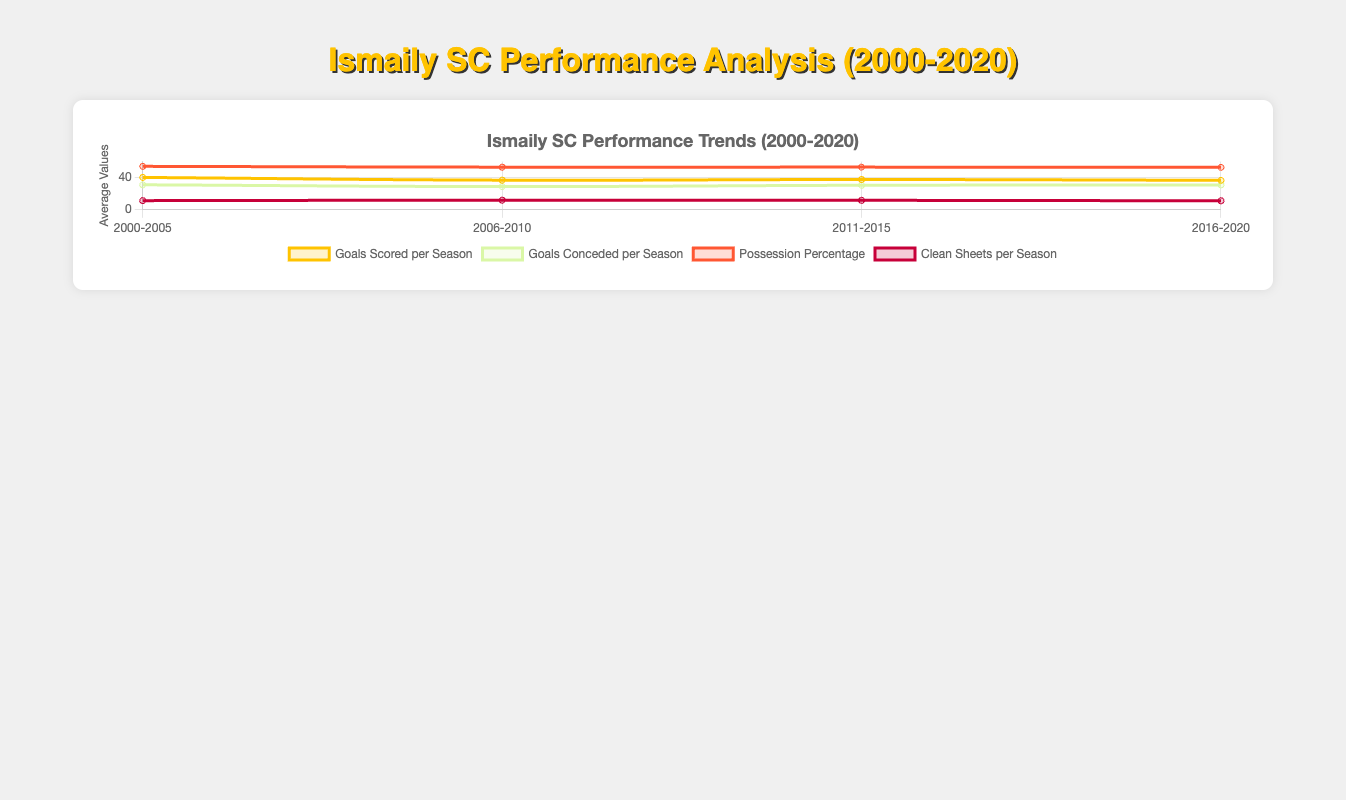What's the average number of goals scored per season for the era 2006-2010? To determine the average, sum the goals scored across the seasons in that era (34 + 39 + 43 + 37 + 31) = 184, and then divide by the number of seasons (5). The average is 184/5 = 36.8
Answer: 36.8 How did the possession percentage change from 2000-2005 to 2016-2020? Compare the average possession percentage of 2000-2005 and 2016-2020. For 2000-2005: (54.2 + 53.8 + 55.1 + 54.5 + 52.7)/5 = 54.06. For 2016-2020: (52.3 + 53.1 + 54.3 + 52.0 + 52.5)/5 = 52.84. There was a decrease from 54.06 to 52.84
Answer: Decreased Which era had the highest clean sheets per season? Analyze the average number of clean sheets per season for each era and identify the highest. The values are: 2000-2005: (12 + 10 + 14 + 11 + 9)/5 = 11.2, 2006-2010: (11 + 12 + 15 + 11 + 10)/5 = 11.8, 2011-2015: (13 + 11 + 14 + 12 + 8)/5 = 11.6, 2016-2020: (10 + 9 + 12 + 11 + 13)/5 = 11.
Answer: 2006-2010 In which era did the number of goals scored per season drop the most compared to the previous era? Subtract the average number of goals per season for each subsequent era from its previous era: 2000-2005: 40.2, 2006-2010: 36.8, 2011-2015: 37.6, 2016-2020: 36.6. The drop: (2000-2005 to 2006-2010) was 40.2 - 36.8 = 3.4, (2006-2010 to 2011-2015) was 36.8 - 37.6 = -0.8, (2011-2015 to 2016-2020) was 37.6 - 36.6 = 1.0. The greatest drop was from 2000-2005 to 2006-2010
Answer: 2000-2005 to 2006-2010 What is the difference in average goals conceded per season between the eras 2011-2015 and 2016-2020? Compute the average goals conceded per season for each era: 2011-2015: (29 + 31 + 27 + 30 + 35)/5 = 30.4, 2016-2020: (32 + 33 + 30 + 31 + 28)/5 = 30.8. The difference is 30.8 - 30.4 = 0.4
Answer: 0.4 Which era has the highest trend in goals scored per season based on the visual representation? Observe the visual peaks of the goals scored per season trendline and compare. The highest era trend should show the strongest upward movement over the years within that era
Answer: 2000-2005 Does the era 2011-2015 show a higher average in possession percentage than 2006-2010? Calculate the possession percentages: For 2006-2010: (51.9 + 54.0 + 55.4 + 53.3 + 50.7)/5 = 53.06, for 2011-2015: (53.5 + 52.9 + 54.8 + 53.1 + 51.2)/5 = 53.1. Compare the averages
Answer: Yes How many more clean sheets per season does 2000-2005 have than 2016-2020? Calculate the difference: 2000-2005 average: 11.2, 2016-2020 average: 11. The difference is 11.2 - 11 = 0.2
Answer: 0.2 Which visual attribute indicates the era with the most consistent performance in all metrics? Look at the smoothness and minimal fluctuations in the lines representing the different stats for each era. Consistency is indicated by minimal variance across metrics over the years. Determine which era's line intervals are the most balanced and uniform
Answer: 2016-2020 